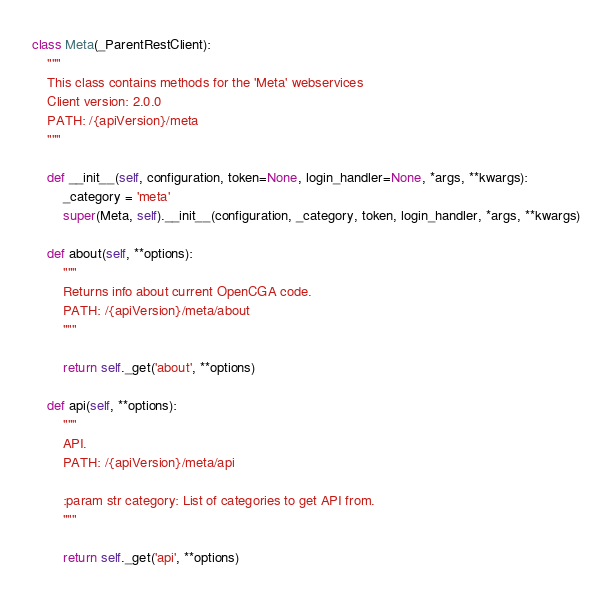<code> <loc_0><loc_0><loc_500><loc_500><_Python_>

class Meta(_ParentRestClient):
    """
    This class contains methods for the 'Meta' webservices
    Client version: 2.0.0
    PATH: /{apiVersion}/meta
    """

    def __init__(self, configuration, token=None, login_handler=None, *args, **kwargs):
        _category = 'meta'
        super(Meta, self).__init__(configuration, _category, token, login_handler, *args, **kwargs)

    def about(self, **options):
        """
        Returns info about current OpenCGA code.
        PATH: /{apiVersion}/meta/about
        """

        return self._get('about', **options)

    def api(self, **options):
        """
        API.
        PATH: /{apiVersion}/meta/api

        :param str category: List of categories to get API from.
        """

        return self._get('api', **options)
</code> 